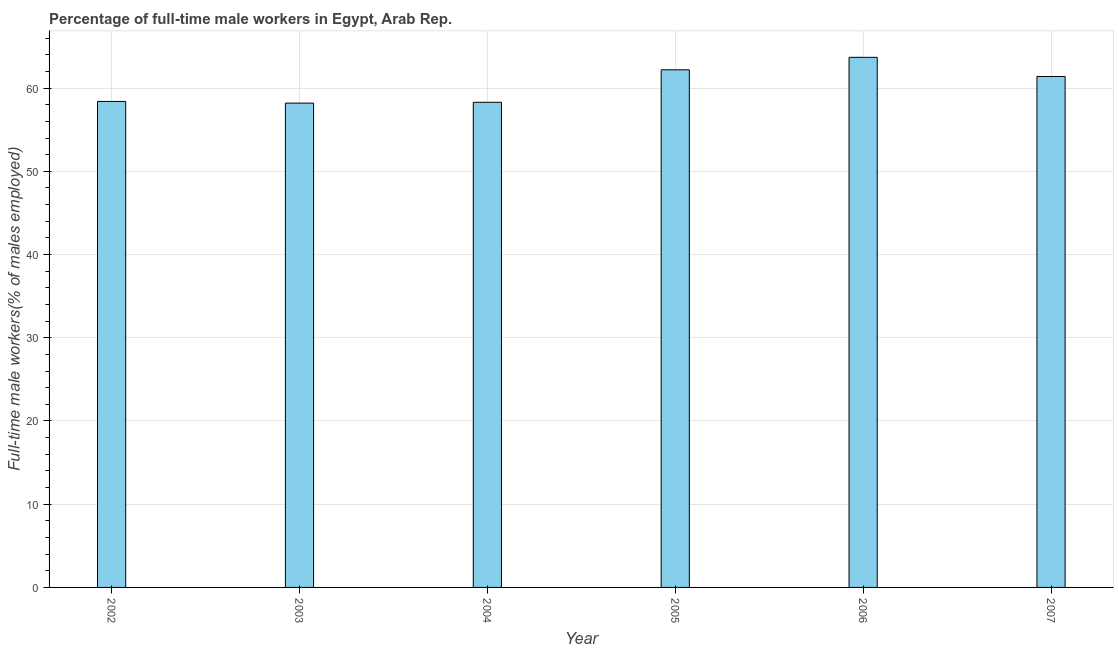Does the graph contain any zero values?
Your answer should be very brief. No. Does the graph contain grids?
Your response must be concise. Yes. What is the title of the graph?
Your response must be concise. Percentage of full-time male workers in Egypt, Arab Rep. What is the label or title of the Y-axis?
Offer a very short reply. Full-time male workers(% of males employed). What is the percentage of full-time male workers in 2007?
Your answer should be compact. 61.4. Across all years, what is the maximum percentage of full-time male workers?
Offer a very short reply. 63.7. Across all years, what is the minimum percentage of full-time male workers?
Provide a short and direct response. 58.2. In which year was the percentage of full-time male workers maximum?
Provide a short and direct response. 2006. In which year was the percentage of full-time male workers minimum?
Keep it short and to the point. 2003. What is the sum of the percentage of full-time male workers?
Offer a terse response. 362.2. What is the average percentage of full-time male workers per year?
Give a very brief answer. 60.37. What is the median percentage of full-time male workers?
Make the answer very short. 59.9. What is the ratio of the percentage of full-time male workers in 2003 to that in 2006?
Give a very brief answer. 0.91. Is the difference between the percentage of full-time male workers in 2006 and 2007 greater than the difference between any two years?
Offer a terse response. No. What is the difference between the highest and the second highest percentage of full-time male workers?
Ensure brevity in your answer.  1.5. Is the sum of the percentage of full-time male workers in 2004 and 2006 greater than the maximum percentage of full-time male workers across all years?
Your answer should be compact. Yes. In how many years, is the percentage of full-time male workers greater than the average percentage of full-time male workers taken over all years?
Offer a very short reply. 3. Are all the bars in the graph horizontal?
Offer a terse response. No. How many years are there in the graph?
Make the answer very short. 6. What is the Full-time male workers(% of males employed) in 2002?
Make the answer very short. 58.4. What is the Full-time male workers(% of males employed) of 2003?
Provide a succinct answer. 58.2. What is the Full-time male workers(% of males employed) of 2004?
Keep it short and to the point. 58.3. What is the Full-time male workers(% of males employed) of 2005?
Provide a succinct answer. 62.2. What is the Full-time male workers(% of males employed) of 2006?
Provide a succinct answer. 63.7. What is the Full-time male workers(% of males employed) of 2007?
Offer a terse response. 61.4. What is the difference between the Full-time male workers(% of males employed) in 2002 and 2004?
Make the answer very short. 0.1. What is the difference between the Full-time male workers(% of males employed) in 2002 and 2006?
Offer a very short reply. -5.3. What is the difference between the Full-time male workers(% of males employed) in 2002 and 2007?
Your response must be concise. -3. What is the difference between the Full-time male workers(% of males employed) in 2004 and 2006?
Give a very brief answer. -5.4. What is the difference between the Full-time male workers(% of males employed) in 2004 and 2007?
Make the answer very short. -3.1. What is the ratio of the Full-time male workers(% of males employed) in 2002 to that in 2003?
Offer a very short reply. 1. What is the ratio of the Full-time male workers(% of males employed) in 2002 to that in 2005?
Provide a short and direct response. 0.94. What is the ratio of the Full-time male workers(% of males employed) in 2002 to that in 2006?
Your response must be concise. 0.92. What is the ratio of the Full-time male workers(% of males employed) in 2002 to that in 2007?
Make the answer very short. 0.95. What is the ratio of the Full-time male workers(% of males employed) in 2003 to that in 2005?
Give a very brief answer. 0.94. What is the ratio of the Full-time male workers(% of males employed) in 2003 to that in 2006?
Offer a terse response. 0.91. What is the ratio of the Full-time male workers(% of males employed) in 2003 to that in 2007?
Make the answer very short. 0.95. What is the ratio of the Full-time male workers(% of males employed) in 2004 to that in 2005?
Provide a succinct answer. 0.94. What is the ratio of the Full-time male workers(% of males employed) in 2004 to that in 2006?
Provide a succinct answer. 0.92. What is the ratio of the Full-time male workers(% of males employed) in 2005 to that in 2007?
Ensure brevity in your answer.  1.01. What is the ratio of the Full-time male workers(% of males employed) in 2006 to that in 2007?
Make the answer very short. 1.04. 